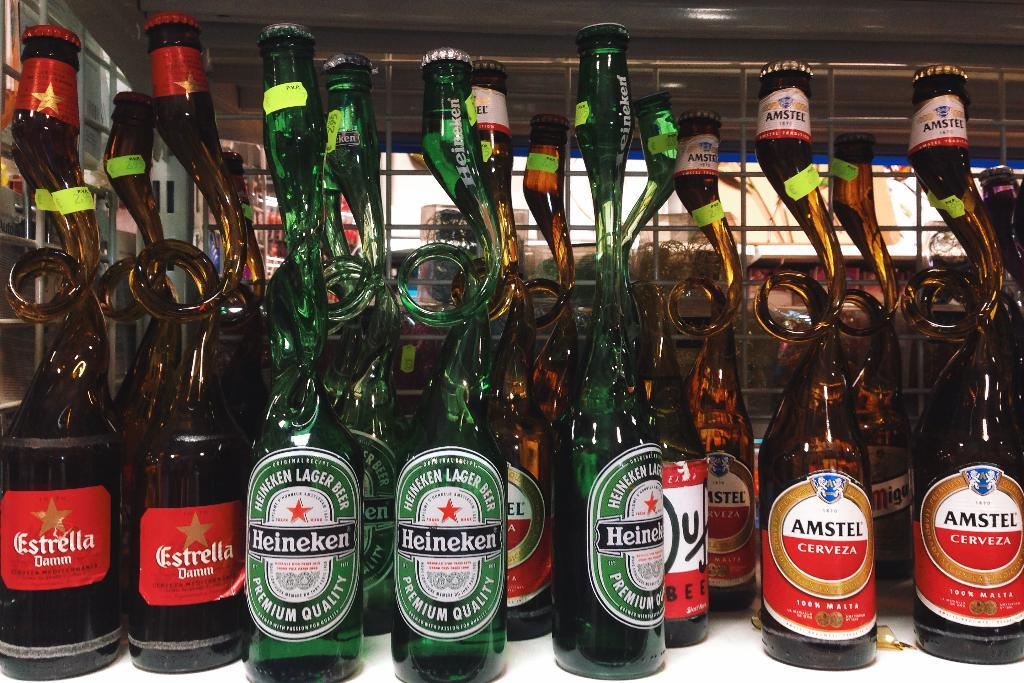What objects are on the table in the image? There are bottles on a table in the image. What type of can is visible in the image? There is no can present in the image; it only features bottles on a table. Is there a cemetery in the background of the image? There is no information about the background of the image, but it does not mention a cemetery. Can you describe any exchange happening in the image? There is no information about any exchange happening in the image; it only features bottles on a table. 